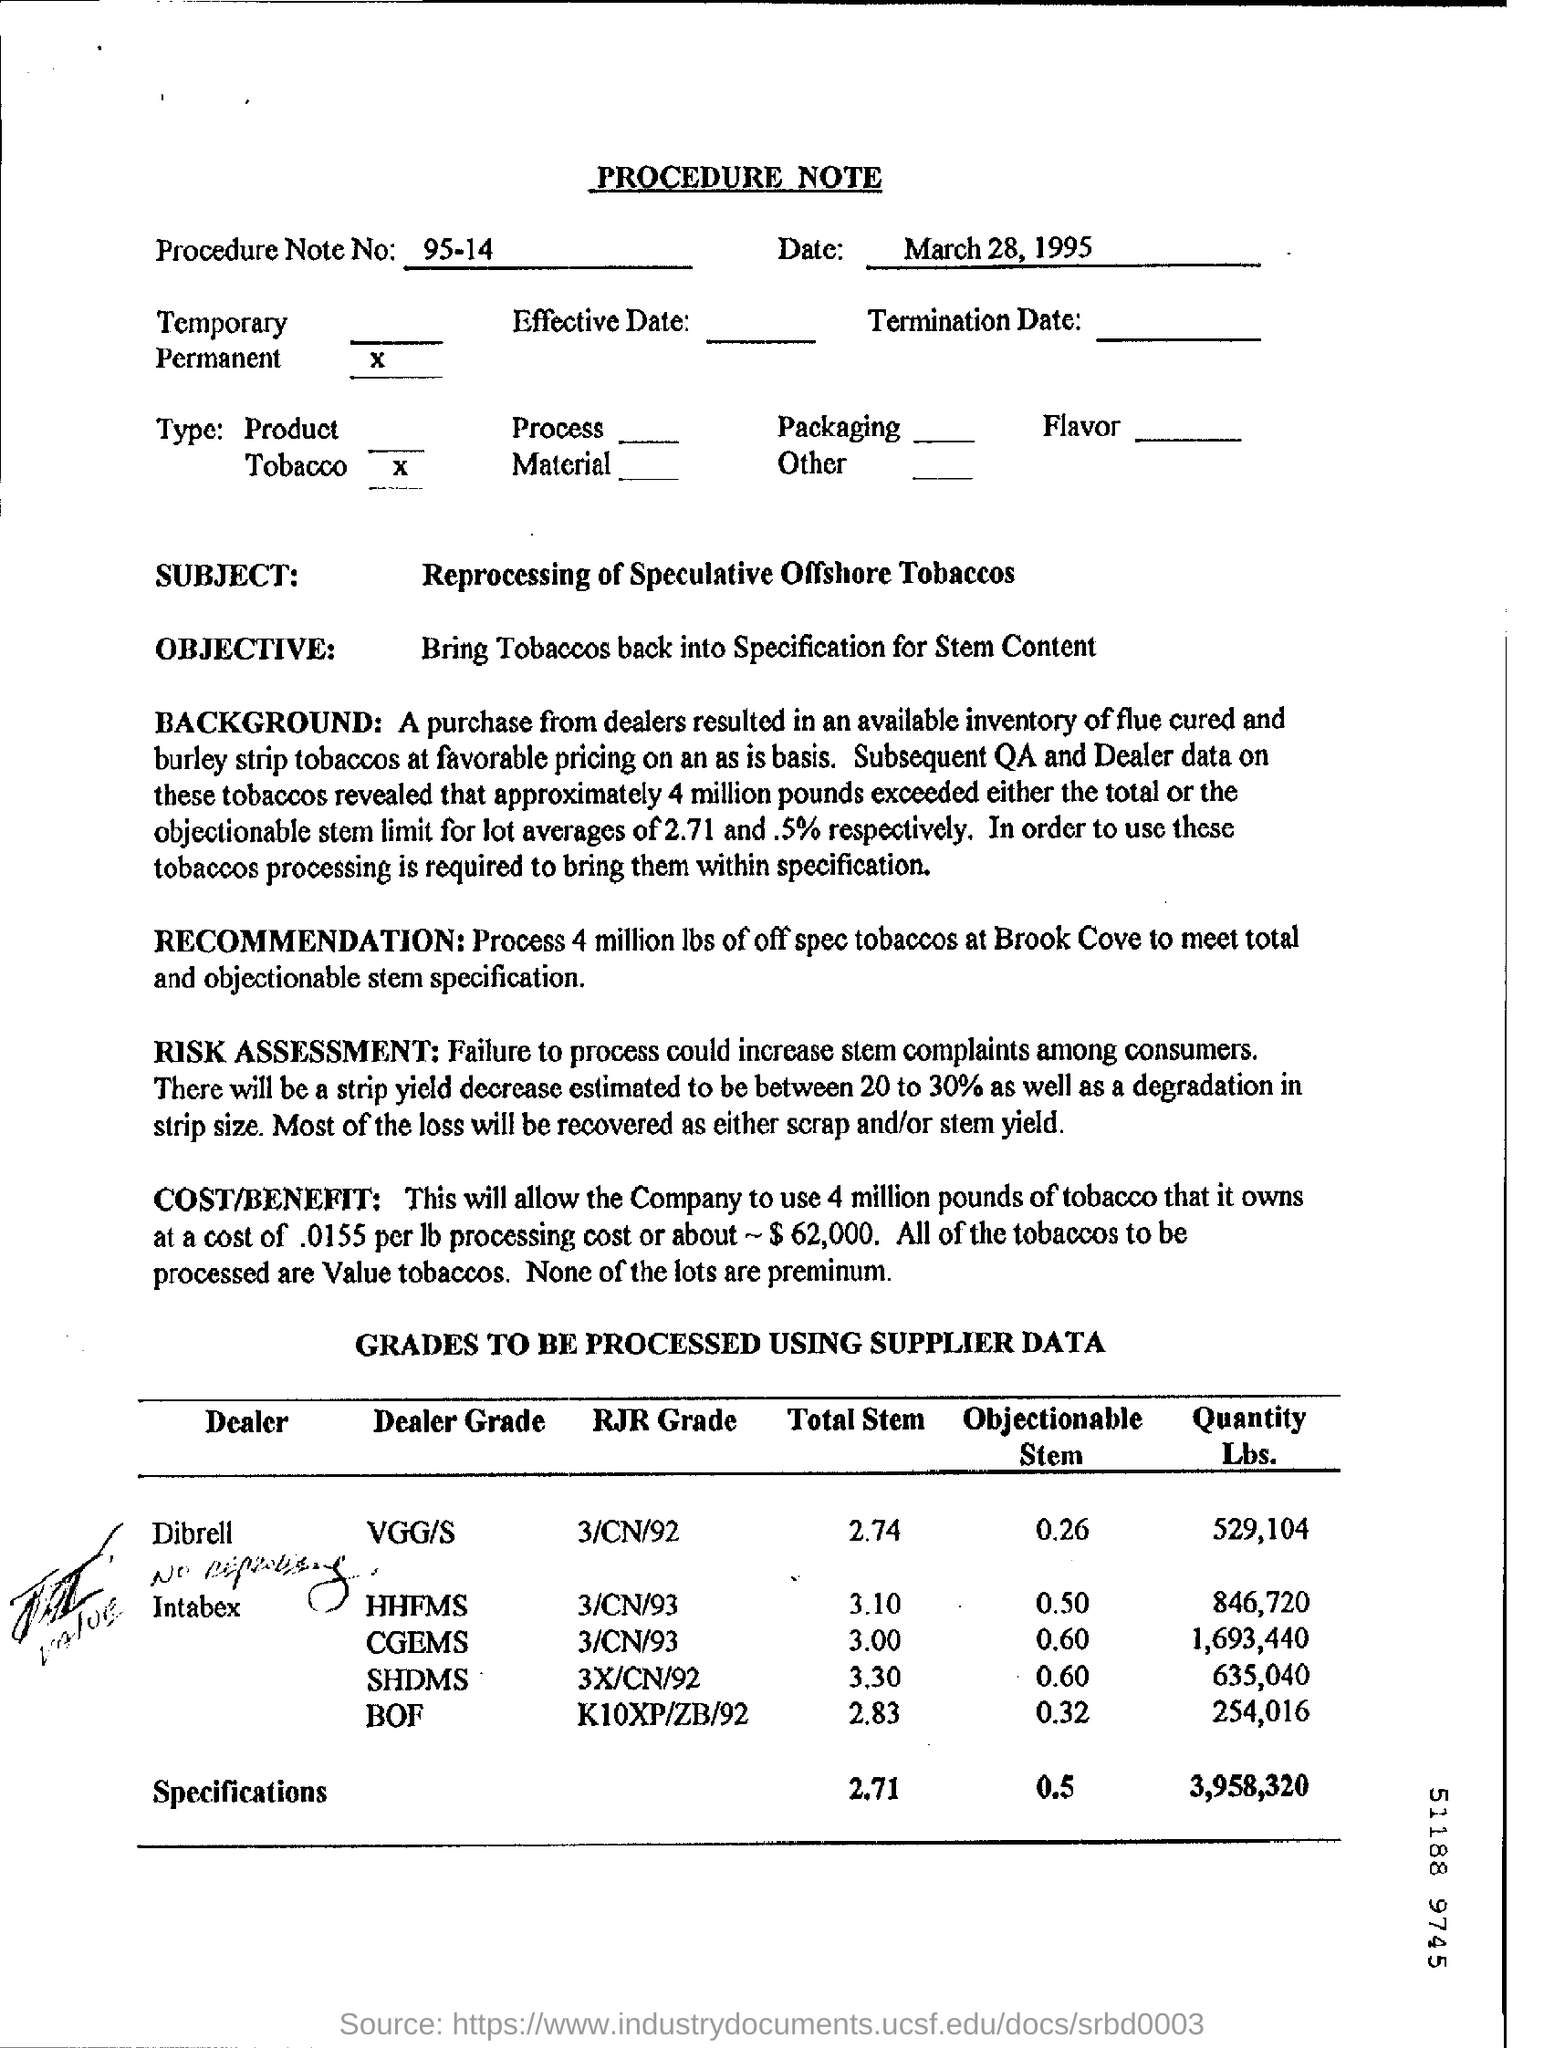Specify some key components in this picture. The objective of the procedure note is to bring tobaccos back into the specification for stem content. The subject of the procedure note is the reprocessing of speculative offshore tobaccos. The procedure note is dated March 28, 1995. The dealer who has 529,104 lbs of tobacco to be processed is Dibrell. The estimated decrease in strip yield ranges from 20 to 30 percent. 